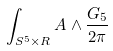<formula> <loc_0><loc_0><loc_500><loc_500>\int _ { S ^ { 5 } \times R } A \wedge \frac { G _ { 5 } } { 2 \pi }</formula> 